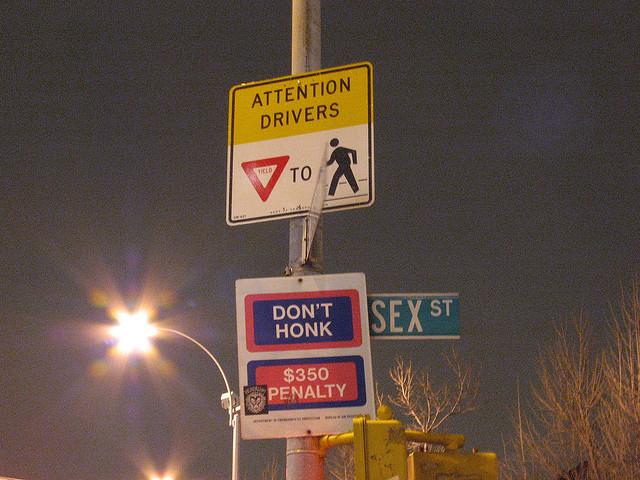What is prohibited?
Give a very brief answer. Honking. What color are the pants on the walk/don't walk sign?
Be succinct. Black. What shape is the red and white object on top of the pole?
Keep it brief. Triangle. What is the weather like in this picture?
Keep it brief. Cloudy. What kind street sign is the sticker on?
Give a very brief answer. Don't honk. What's the name of the street sign in blue?
Concise answer only. Sex st. What colors are shown below the sign?
Give a very brief answer. Yellow. Is this daytime or night time?
Quick response, please. Night. How much is the penalty?
Write a very short answer. $350. Is it safe to cross the street?
Short answer required. Yes. What is the name of the street?
Keep it brief. Sex. What does the campaign sign say?
Answer briefly. Don't honk. What street is the picture taken on?
Answer briefly. Sex. What language is on the sign?
Quick response, please. English. How many signs are there?
Be succinct. 3. 